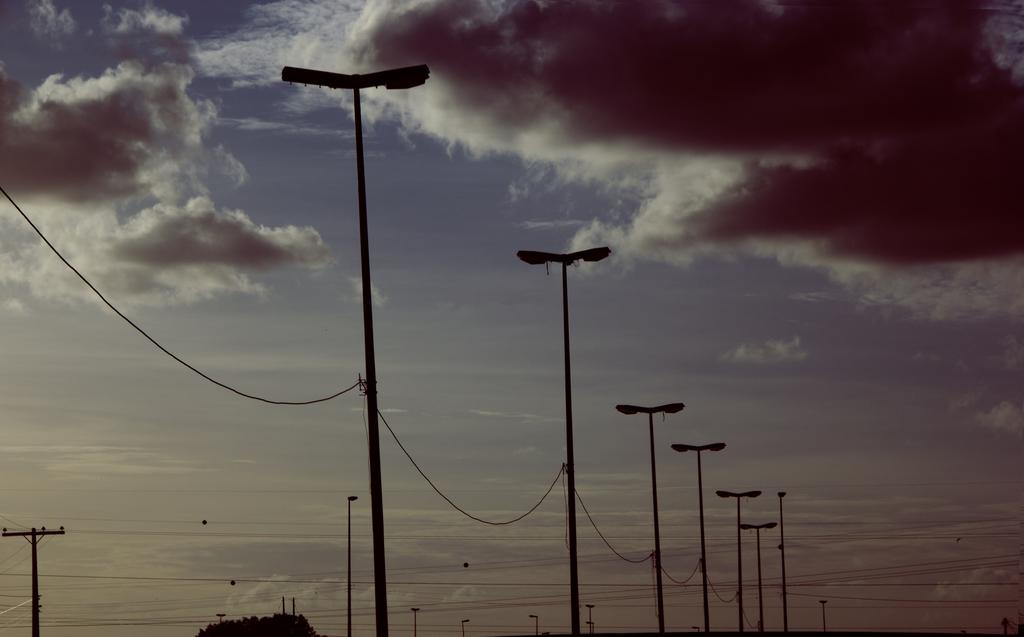What structures are present in the image? There are street lamp poles in the image. What is visible in the background of the image? The sky is visible in the image. How would you describe the sky in the image? The sky appears to be cloudy. How many eggs are being shown in the image? There are no eggs present in the image. Can you describe the group of people in the image? There is no group of people present in the image. 